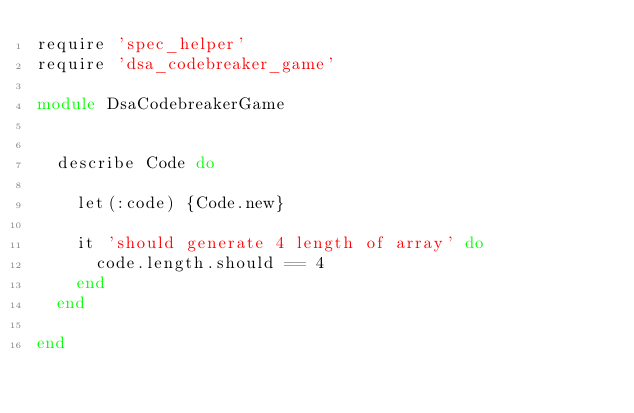<code> <loc_0><loc_0><loc_500><loc_500><_Ruby_>require 'spec_helper'
require 'dsa_codebreaker_game'

module DsaCodebreakerGame


  describe Code do

    let(:code) {Code.new}

    it 'should generate 4 length of array' do
      code.length.should == 4
    end
  end

end</code> 